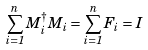Convert formula to latex. <formula><loc_0><loc_0><loc_500><loc_500>\sum _ { i = 1 } ^ { n } M _ { i } ^ { \dagger } M _ { i } = \sum _ { i = 1 } ^ { n } F _ { i } = I</formula> 